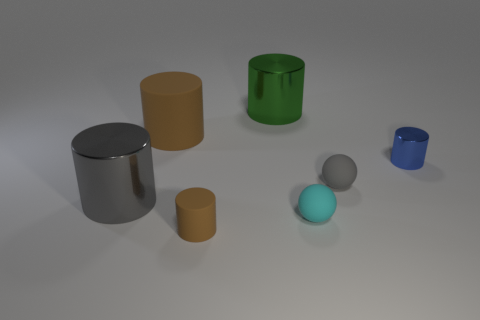The big metal cylinder on the right side of the large metal object that is left of the brown matte cylinder in front of the blue shiny cylinder is what color?
Provide a succinct answer. Green. What number of metallic objects are small blue cylinders or cyan spheres?
Provide a short and direct response. 1. Are there more matte balls that are to the left of the large green metallic cylinder than gray matte balls that are behind the small blue metallic cylinder?
Your response must be concise. No. How many other things are there of the same size as the gray cylinder?
Make the answer very short. 2. There is a brown matte cylinder in front of the brown matte cylinder behind the tiny gray ball; how big is it?
Offer a very short reply. Small. What number of tiny objects are either cyan rubber things or balls?
Make the answer very short. 2. There is a cylinder behind the brown cylinder behind the brown rubber cylinder that is in front of the tiny blue metallic cylinder; what size is it?
Ensure brevity in your answer.  Large. Are there any other things of the same color as the small metal cylinder?
Provide a short and direct response. No. What material is the gray object right of the gray object on the left side of the brown cylinder in front of the gray matte ball made of?
Offer a terse response. Rubber. Do the tiny cyan matte thing and the large brown matte object have the same shape?
Give a very brief answer. No. 